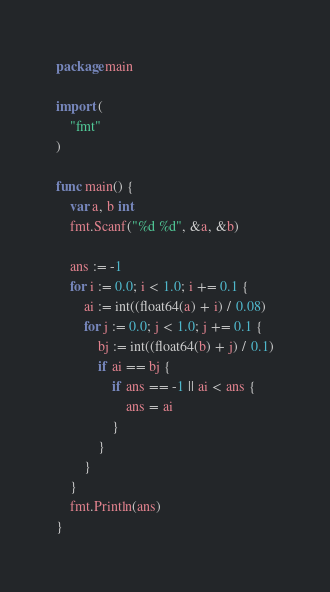<code> <loc_0><loc_0><loc_500><loc_500><_Go_>package main

import (
	"fmt"
)

func main() {
	var a, b int
	fmt.Scanf("%d %d", &a, &b)

	ans := -1
	for i := 0.0; i < 1.0; i += 0.1 {
		ai := int((float64(a) + i) / 0.08)
		for j := 0.0; j < 1.0; j += 0.1 {
			bj := int((float64(b) + j) / 0.1)
			if ai == bj {
				if ans == -1 || ai < ans {
					ans = ai
				}
			}
		}
	}
	fmt.Println(ans)
}
</code> 